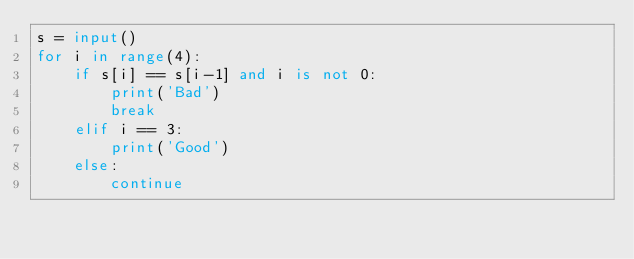Convert code to text. <code><loc_0><loc_0><loc_500><loc_500><_Python_>s = input()
for i in range(4):
    if s[i] == s[i-1] and i is not 0:
        print('Bad')
        break
    elif i == 3:
        print('Good')
    else:
        continue</code> 